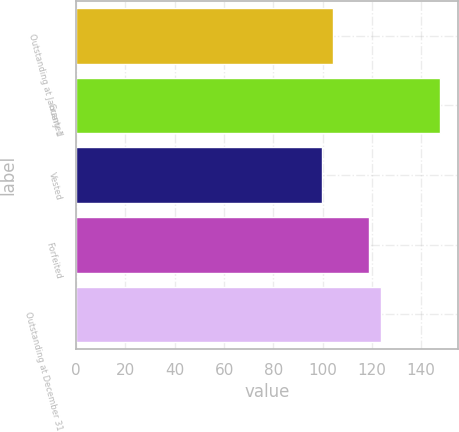Convert chart. <chart><loc_0><loc_0><loc_500><loc_500><bar_chart><fcel>Outstanding at January 1<fcel>Granted<fcel>Vested<fcel>Forfeited<fcel>Outstanding at December 31<nl><fcel>104.34<fcel>147.44<fcel>99.55<fcel>118.82<fcel>123.61<nl></chart> 